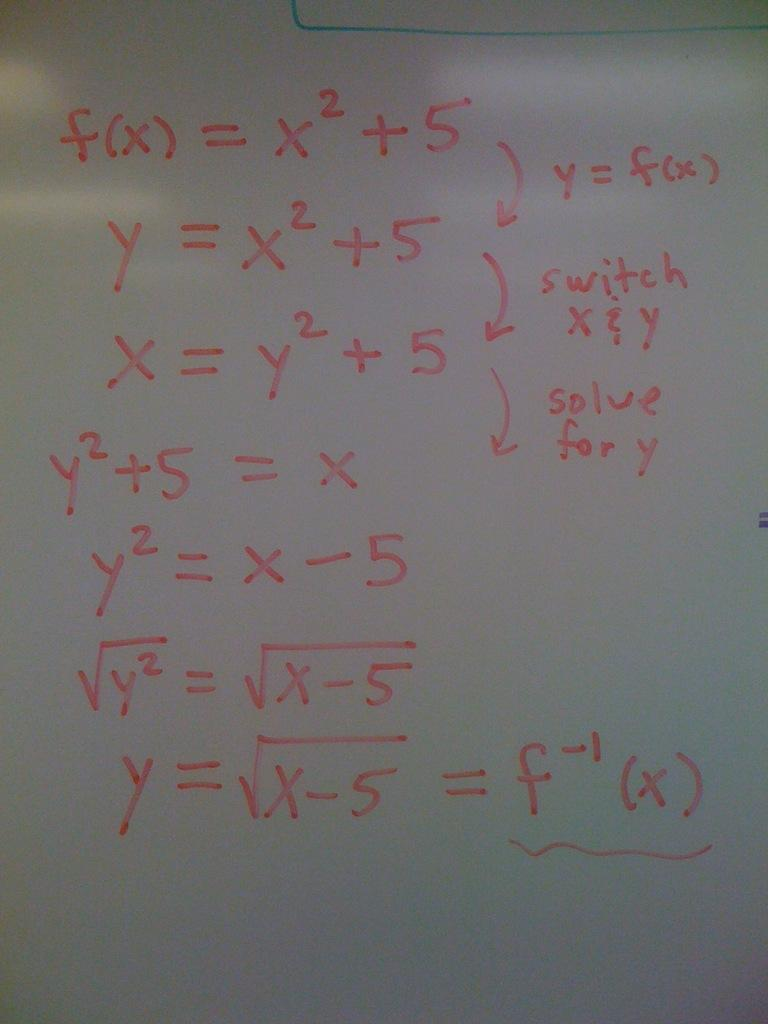<image>
Summarize the visual content of the image. White board which shows equations in cluding one which has the answer of fx. 